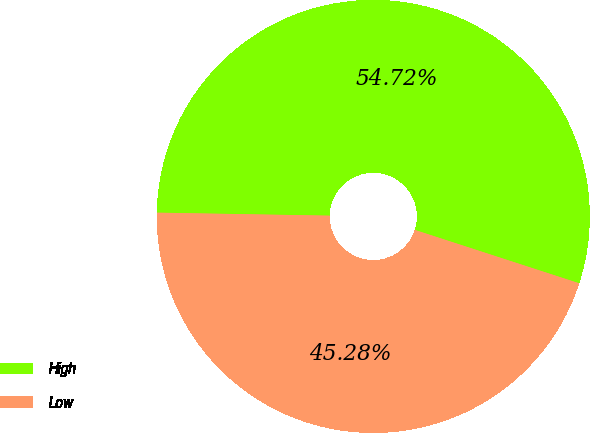Convert chart. <chart><loc_0><loc_0><loc_500><loc_500><pie_chart><fcel>High<fcel>Low<nl><fcel>54.72%<fcel>45.28%<nl></chart> 